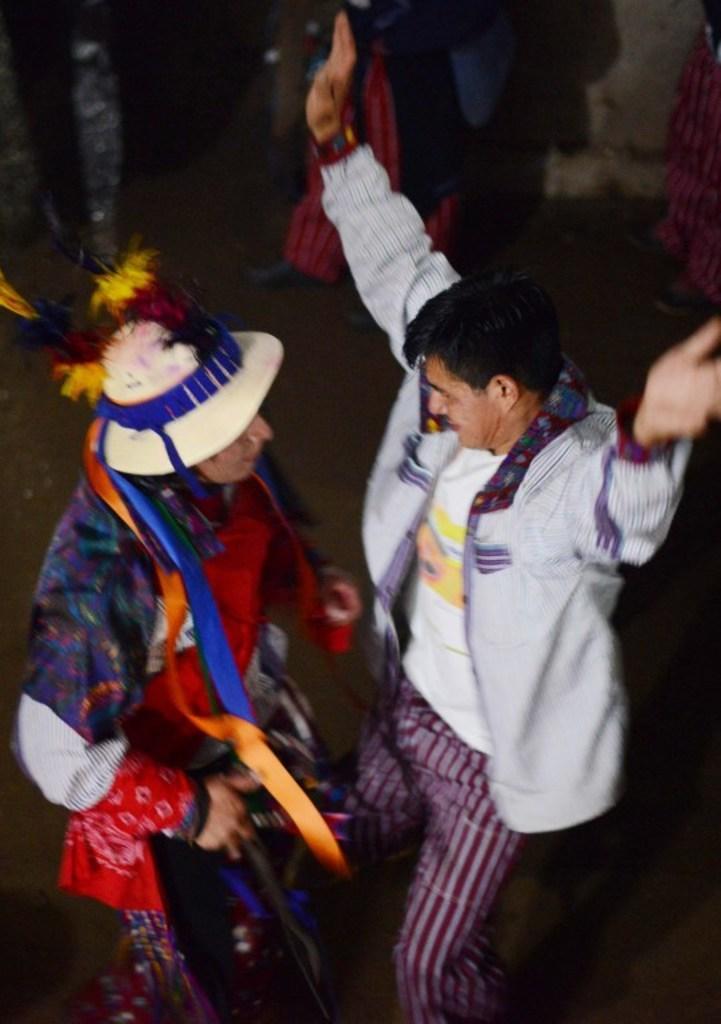Can you describe this image briefly? In the image in the center we can see two people were dancing and they were in different costumes. In the background there is a wall and few people were standing. 